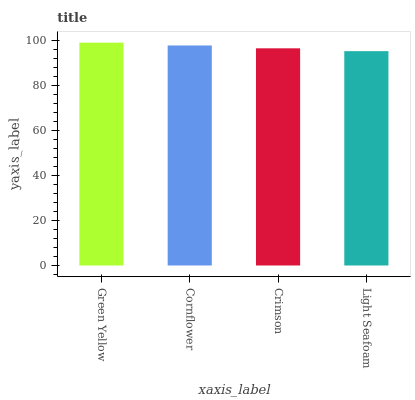Is Light Seafoam the minimum?
Answer yes or no. Yes. Is Green Yellow the maximum?
Answer yes or no. Yes. Is Cornflower the minimum?
Answer yes or no. No. Is Cornflower the maximum?
Answer yes or no. No. Is Green Yellow greater than Cornflower?
Answer yes or no. Yes. Is Cornflower less than Green Yellow?
Answer yes or no. Yes. Is Cornflower greater than Green Yellow?
Answer yes or no. No. Is Green Yellow less than Cornflower?
Answer yes or no. No. Is Cornflower the high median?
Answer yes or no. Yes. Is Crimson the low median?
Answer yes or no. Yes. Is Light Seafoam the high median?
Answer yes or no. No. Is Cornflower the low median?
Answer yes or no. No. 